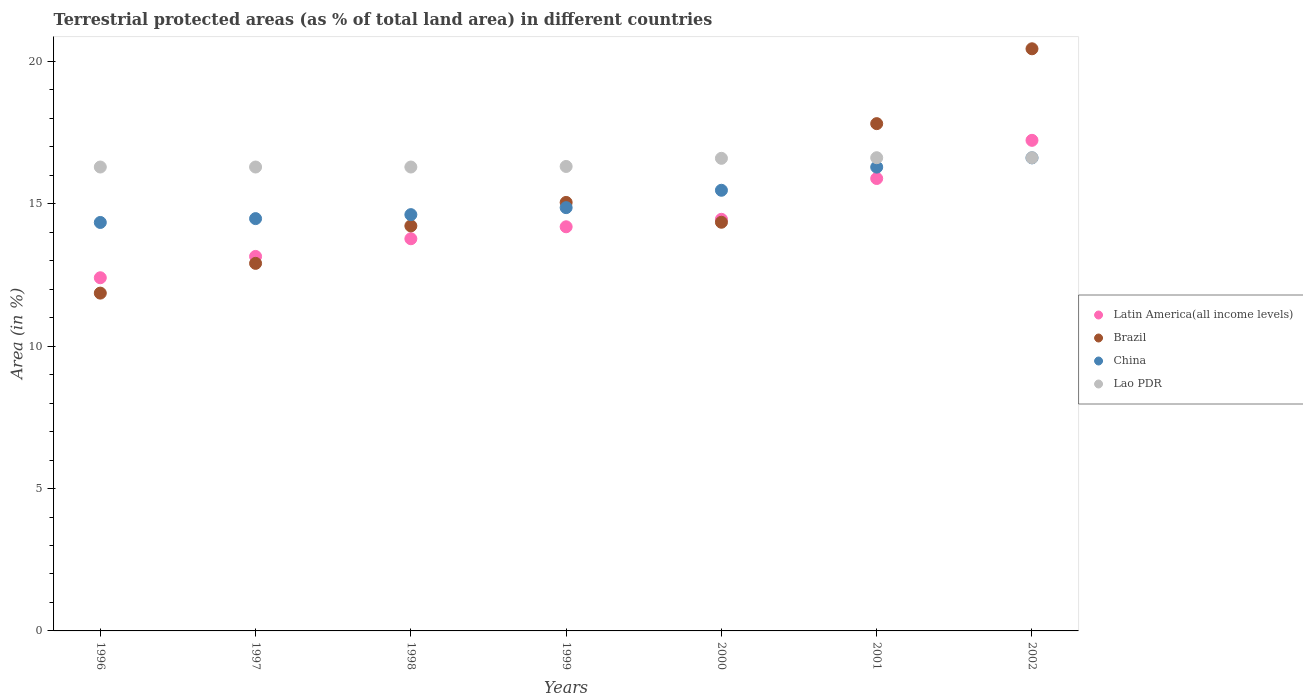What is the percentage of terrestrial protected land in China in 2001?
Offer a very short reply. 16.29. Across all years, what is the maximum percentage of terrestrial protected land in Latin America(all income levels)?
Give a very brief answer. 17.23. Across all years, what is the minimum percentage of terrestrial protected land in Latin America(all income levels)?
Provide a short and direct response. 12.4. In which year was the percentage of terrestrial protected land in Latin America(all income levels) maximum?
Keep it short and to the point. 2002. In which year was the percentage of terrestrial protected land in Lao PDR minimum?
Provide a short and direct response. 1996. What is the total percentage of terrestrial protected land in Latin America(all income levels) in the graph?
Offer a terse response. 101.09. What is the difference between the percentage of terrestrial protected land in China in 2000 and that in 2002?
Provide a succinct answer. -1.14. What is the difference between the percentage of terrestrial protected land in Latin America(all income levels) in 1997 and the percentage of terrestrial protected land in Brazil in 1999?
Offer a terse response. -1.9. What is the average percentage of terrestrial protected land in Brazil per year?
Provide a short and direct response. 15.24. In the year 2002, what is the difference between the percentage of terrestrial protected land in Brazil and percentage of terrestrial protected land in China?
Offer a terse response. 3.83. What is the ratio of the percentage of terrestrial protected land in Brazil in 1997 to that in 2002?
Provide a short and direct response. 0.63. Is the percentage of terrestrial protected land in China in 1999 less than that in 2001?
Provide a short and direct response. Yes. What is the difference between the highest and the second highest percentage of terrestrial protected land in Latin America(all income levels)?
Your answer should be compact. 1.34. What is the difference between the highest and the lowest percentage of terrestrial protected land in Latin America(all income levels)?
Give a very brief answer. 4.83. Is the sum of the percentage of terrestrial protected land in Lao PDR in 1998 and 2002 greater than the maximum percentage of terrestrial protected land in Brazil across all years?
Your response must be concise. Yes. Is it the case that in every year, the sum of the percentage of terrestrial protected land in Latin America(all income levels) and percentage of terrestrial protected land in China  is greater than the sum of percentage of terrestrial protected land in Lao PDR and percentage of terrestrial protected land in Brazil?
Your response must be concise. No. Does the percentage of terrestrial protected land in Brazil monotonically increase over the years?
Provide a succinct answer. No. Is the percentage of terrestrial protected land in Latin America(all income levels) strictly greater than the percentage of terrestrial protected land in Lao PDR over the years?
Make the answer very short. No. Is the percentage of terrestrial protected land in Brazil strictly less than the percentage of terrestrial protected land in Latin America(all income levels) over the years?
Your answer should be compact. No. How many dotlines are there?
Give a very brief answer. 4. How many years are there in the graph?
Provide a succinct answer. 7. Are the values on the major ticks of Y-axis written in scientific E-notation?
Provide a short and direct response. No. Does the graph contain any zero values?
Make the answer very short. No. Does the graph contain grids?
Ensure brevity in your answer.  No. Where does the legend appear in the graph?
Keep it short and to the point. Center right. How many legend labels are there?
Offer a very short reply. 4. How are the legend labels stacked?
Offer a very short reply. Vertical. What is the title of the graph?
Ensure brevity in your answer.  Terrestrial protected areas (as % of total land area) in different countries. Does "St. Lucia" appear as one of the legend labels in the graph?
Provide a succinct answer. No. What is the label or title of the Y-axis?
Your answer should be very brief. Area (in %). What is the Area (in %) in Latin America(all income levels) in 1996?
Offer a very short reply. 12.4. What is the Area (in %) in Brazil in 1996?
Ensure brevity in your answer.  11.86. What is the Area (in %) in China in 1996?
Your answer should be very brief. 14.34. What is the Area (in %) in Lao PDR in 1996?
Ensure brevity in your answer.  16.29. What is the Area (in %) of Latin America(all income levels) in 1997?
Provide a short and direct response. 13.15. What is the Area (in %) of Brazil in 1997?
Your answer should be compact. 12.91. What is the Area (in %) of China in 1997?
Ensure brevity in your answer.  14.48. What is the Area (in %) in Lao PDR in 1997?
Keep it short and to the point. 16.29. What is the Area (in %) of Latin America(all income levels) in 1998?
Your answer should be very brief. 13.77. What is the Area (in %) in Brazil in 1998?
Provide a succinct answer. 14.22. What is the Area (in %) of China in 1998?
Your answer should be compact. 14.62. What is the Area (in %) of Lao PDR in 1998?
Provide a short and direct response. 16.29. What is the Area (in %) of Latin America(all income levels) in 1999?
Offer a terse response. 14.19. What is the Area (in %) in Brazil in 1999?
Offer a terse response. 15.05. What is the Area (in %) in China in 1999?
Your response must be concise. 14.86. What is the Area (in %) of Lao PDR in 1999?
Your answer should be very brief. 16.31. What is the Area (in %) in Latin America(all income levels) in 2000?
Your answer should be compact. 14.46. What is the Area (in %) in Brazil in 2000?
Offer a very short reply. 14.35. What is the Area (in %) of China in 2000?
Offer a terse response. 15.47. What is the Area (in %) of Lao PDR in 2000?
Your response must be concise. 16.6. What is the Area (in %) of Latin America(all income levels) in 2001?
Keep it short and to the point. 15.89. What is the Area (in %) in Brazil in 2001?
Make the answer very short. 17.81. What is the Area (in %) in China in 2001?
Your answer should be compact. 16.29. What is the Area (in %) in Lao PDR in 2001?
Your answer should be very brief. 16.62. What is the Area (in %) in Latin America(all income levels) in 2002?
Offer a terse response. 17.23. What is the Area (in %) in Brazil in 2002?
Your answer should be very brief. 20.44. What is the Area (in %) of China in 2002?
Provide a short and direct response. 16.61. What is the Area (in %) of Lao PDR in 2002?
Provide a short and direct response. 16.62. Across all years, what is the maximum Area (in %) of Latin America(all income levels)?
Your response must be concise. 17.23. Across all years, what is the maximum Area (in %) of Brazil?
Offer a very short reply. 20.44. Across all years, what is the maximum Area (in %) in China?
Provide a short and direct response. 16.61. Across all years, what is the maximum Area (in %) of Lao PDR?
Provide a succinct answer. 16.62. Across all years, what is the minimum Area (in %) in Latin America(all income levels)?
Offer a terse response. 12.4. Across all years, what is the minimum Area (in %) of Brazil?
Your answer should be very brief. 11.86. Across all years, what is the minimum Area (in %) of China?
Provide a short and direct response. 14.34. Across all years, what is the minimum Area (in %) of Lao PDR?
Make the answer very short. 16.29. What is the total Area (in %) of Latin America(all income levels) in the graph?
Provide a short and direct response. 101.09. What is the total Area (in %) in Brazil in the graph?
Provide a short and direct response. 106.65. What is the total Area (in %) in China in the graph?
Give a very brief answer. 106.68. What is the total Area (in %) of Lao PDR in the graph?
Offer a terse response. 115.02. What is the difference between the Area (in %) of Latin America(all income levels) in 1996 and that in 1997?
Provide a succinct answer. -0.75. What is the difference between the Area (in %) in Brazil in 1996 and that in 1997?
Your answer should be compact. -1.04. What is the difference between the Area (in %) in China in 1996 and that in 1997?
Provide a succinct answer. -0.13. What is the difference between the Area (in %) of Lao PDR in 1996 and that in 1997?
Provide a short and direct response. 0. What is the difference between the Area (in %) in Latin America(all income levels) in 1996 and that in 1998?
Your response must be concise. -1.37. What is the difference between the Area (in %) of Brazil in 1996 and that in 1998?
Offer a very short reply. -2.36. What is the difference between the Area (in %) of China in 1996 and that in 1998?
Offer a very short reply. -0.27. What is the difference between the Area (in %) of Latin America(all income levels) in 1996 and that in 1999?
Your answer should be compact. -1.79. What is the difference between the Area (in %) in Brazil in 1996 and that in 1999?
Your answer should be very brief. -3.19. What is the difference between the Area (in %) in China in 1996 and that in 1999?
Keep it short and to the point. -0.52. What is the difference between the Area (in %) of Lao PDR in 1996 and that in 1999?
Keep it short and to the point. -0.02. What is the difference between the Area (in %) in Latin America(all income levels) in 1996 and that in 2000?
Make the answer very short. -2.05. What is the difference between the Area (in %) of Brazil in 1996 and that in 2000?
Provide a succinct answer. -2.49. What is the difference between the Area (in %) of China in 1996 and that in 2000?
Keep it short and to the point. -1.13. What is the difference between the Area (in %) of Lao PDR in 1996 and that in 2000?
Provide a succinct answer. -0.31. What is the difference between the Area (in %) of Latin America(all income levels) in 1996 and that in 2001?
Keep it short and to the point. -3.49. What is the difference between the Area (in %) in Brazil in 1996 and that in 2001?
Keep it short and to the point. -5.95. What is the difference between the Area (in %) of China in 1996 and that in 2001?
Provide a short and direct response. -1.94. What is the difference between the Area (in %) of Lao PDR in 1996 and that in 2001?
Provide a succinct answer. -0.33. What is the difference between the Area (in %) of Latin America(all income levels) in 1996 and that in 2002?
Make the answer very short. -4.83. What is the difference between the Area (in %) in Brazil in 1996 and that in 2002?
Your response must be concise. -8.58. What is the difference between the Area (in %) of China in 1996 and that in 2002?
Give a very brief answer. -2.27. What is the difference between the Area (in %) of Lao PDR in 1996 and that in 2002?
Make the answer very short. -0.33. What is the difference between the Area (in %) of Latin America(all income levels) in 1997 and that in 1998?
Offer a very short reply. -0.62. What is the difference between the Area (in %) of Brazil in 1997 and that in 1998?
Provide a short and direct response. -1.31. What is the difference between the Area (in %) of China in 1997 and that in 1998?
Provide a short and direct response. -0.14. What is the difference between the Area (in %) in Lao PDR in 1997 and that in 1998?
Keep it short and to the point. 0. What is the difference between the Area (in %) in Latin America(all income levels) in 1997 and that in 1999?
Give a very brief answer. -1.04. What is the difference between the Area (in %) of Brazil in 1997 and that in 1999?
Ensure brevity in your answer.  -2.14. What is the difference between the Area (in %) in China in 1997 and that in 1999?
Your answer should be very brief. -0.39. What is the difference between the Area (in %) of Lao PDR in 1997 and that in 1999?
Ensure brevity in your answer.  -0.02. What is the difference between the Area (in %) in Latin America(all income levels) in 1997 and that in 2000?
Provide a succinct answer. -1.3. What is the difference between the Area (in %) of Brazil in 1997 and that in 2000?
Ensure brevity in your answer.  -1.44. What is the difference between the Area (in %) of China in 1997 and that in 2000?
Ensure brevity in your answer.  -1. What is the difference between the Area (in %) in Lao PDR in 1997 and that in 2000?
Make the answer very short. -0.31. What is the difference between the Area (in %) in Latin America(all income levels) in 1997 and that in 2001?
Offer a terse response. -2.74. What is the difference between the Area (in %) in Brazil in 1997 and that in 2001?
Ensure brevity in your answer.  -4.91. What is the difference between the Area (in %) in China in 1997 and that in 2001?
Offer a very short reply. -1.81. What is the difference between the Area (in %) in Lao PDR in 1997 and that in 2001?
Offer a very short reply. -0.33. What is the difference between the Area (in %) in Latin America(all income levels) in 1997 and that in 2002?
Your answer should be very brief. -4.08. What is the difference between the Area (in %) in Brazil in 1997 and that in 2002?
Your answer should be very brief. -7.54. What is the difference between the Area (in %) of China in 1997 and that in 2002?
Offer a terse response. -2.13. What is the difference between the Area (in %) in Lao PDR in 1997 and that in 2002?
Ensure brevity in your answer.  -0.33. What is the difference between the Area (in %) of Latin America(all income levels) in 1998 and that in 1999?
Ensure brevity in your answer.  -0.42. What is the difference between the Area (in %) of Brazil in 1998 and that in 1999?
Give a very brief answer. -0.82. What is the difference between the Area (in %) in China in 1998 and that in 1999?
Provide a short and direct response. -0.25. What is the difference between the Area (in %) of Lao PDR in 1998 and that in 1999?
Make the answer very short. -0.02. What is the difference between the Area (in %) in Latin America(all income levels) in 1998 and that in 2000?
Ensure brevity in your answer.  -0.68. What is the difference between the Area (in %) in Brazil in 1998 and that in 2000?
Your answer should be very brief. -0.13. What is the difference between the Area (in %) of China in 1998 and that in 2000?
Your answer should be compact. -0.86. What is the difference between the Area (in %) in Lao PDR in 1998 and that in 2000?
Provide a succinct answer. -0.31. What is the difference between the Area (in %) in Latin America(all income levels) in 1998 and that in 2001?
Give a very brief answer. -2.12. What is the difference between the Area (in %) of Brazil in 1998 and that in 2001?
Ensure brevity in your answer.  -3.59. What is the difference between the Area (in %) in China in 1998 and that in 2001?
Provide a succinct answer. -1.67. What is the difference between the Area (in %) of Lao PDR in 1998 and that in 2001?
Give a very brief answer. -0.33. What is the difference between the Area (in %) in Latin America(all income levels) in 1998 and that in 2002?
Provide a short and direct response. -3.46. What is the difference between the Area (in %) in Brazil in 1998 and that in 2002?
Make the answer very short. -6.22. What is the difference between the Area (in %) of China in 1998 and that in 2002?
Your answer should be compact. -1.99. What is the difference between the Area (in %) in Lao PDR in 1998 and that in 2002?
Offer a terse response. -0.33. What is the difference between the Area (in %) in Latin America(all income levels) in 1999 and that in 2000?
Offer a very short reply. -0.26. What is the difference between the Area (in %) in Brazil in 1999 and that in 2000?
Make the answer very short. 0.7. What is the difference between the Area (in %) in China in 1999 and that in 2000?
Provide a short and direct response. -0.61. What is the difference between the Area (in %) in Lao PDR in 1999 and that in 2000?
Keep it short and to the point. -0.29. What is the difference between the Area (in %) in Latin America(all income levels) in 1999 and that in 2001?
Offer a terse response. -1.7. What is the difference between the Area (in %) in Brazil in 1999 and that in 2001?
Offer a terse response. -2.77. What is the difference between the Area (in %) of China in 1999 and that in 2001?
Keep it short and to the point. -1.42. What is the difference between the Area (in %) in Lao PDR in 1999 and that in 2001?
Provide a short and direct response. -0.31. What is the difference between the Area (in %) in Latin America(all income levels) in 1999 and that in 2002?
Provide a short and direct response. -3.04. What is the difference between the Area (in %) in Brazil in 1999 and that in 2002?
Make the answer very short. -5.4. What is the difference between the Area (in %) in China in 1999 and that in 2002?
Keep it short and to the point. -1.75. What is the difference between the Area (in %) of Lao PDR in 1999 and that in 2002?
Your answer should be very brief. -0.31. What is the difference between the Area (in %) of Latin America(all income levels) in 2000 and that in 2001?
Your response must be concise. -1.43. What is the difference between the Area (in %) in Brazil in 2000 and that in 2001?
Give a very brief answer. -3.46. What is the difference between the Area (in %) in China in 2000 and that in 2001?
Your response must be concise. -0.81. What is the difference between the Area (in %) of Lao PDR in 2000 and that in 2001?
Your answer should be compact. -0.02. What is the difference between the Area (in %) in Latin America(all income levels) in 2000 and that in 2002?
Your answer should be very brief. -2.77. What is the difference between the Area (in %) in Brazil in 2000 and that in 2002?
Provide a succinct answer. -6.09. What is the difference between the Area (in %) of China in 2000 and that in 2002?
Provide a succinct answer. -1.14. What is the difference between the Area (in %) of Lao PDR in 2000 and that in 2002?
Your answer should be compact. -0.02. What is the difference between the Area (in %) in Latin America(all income levels) in 2001 and that in 2002?
Your answer should be very brief. -1.34. What is the difference between the Area (in %) of Brazil in 2001 and that in 2002?
Ensure brevity in your answer.  -2.63. What is the difference between the Area (in %) in China in 2001 and that in 2002?
Offer a terse response. -0.33. What is the difference between the Area (in %) of Latin America(all income levels) in 1996 and the Area (in %) of Brazil in 1997?
Keep it short and to the point. -0.51. What is the difference between the Area (in %) in Latin America(all income levels) in 1996 and the Area (in %) in China in 1997?
Your response must be concise. -2.08. What is the difference between the Area (in %) of Latin America(all income levels) in 1996 and the Area (in %) of Lao PDR in 1997?
Your answer should be compact. -3.89. What is the difference between the Area (in %) in Brazil in 1996 and the Area (in %) in China in 1997?
Give a very brief answer. -2.62. What is the difference between the Area (in %) in Brazil in 1996 and the Area (in %) in Lao PDR in 1997?
Provide a succinct answer. -4.43. What is the difference between the Area (in %) of China in 1996 and the Area (in %) of Lao PDR in 1997?
Make the answer very short. -1.95. What is the difference between the Area (in %) of Latin America(all income levels) in 1996 and the Area (in %) of Brazil in 1998?
Provide a short and direct response. -1.82. What is the difference between the Area (in %) of Latin America(all income levels) in 1996 and the Area (in %) of China in 1998?
Your answer should be compact. -2.22. What is the difference between the Area (in %) of Latin America(all income levels) in 1996 and the Area (in %) of Lao PDR in 1998?
Your answer should be compact. -3.89. What is the difference between the Area (in %) in Brazil in 1996 and the Area (in %) in China in 1998?
Ensure brevity in your answer.  -2.76. What is the difference between the Area (in %) in Brazil in 1996 and the Area (in %) in Lao PDR in 1998?
Provide a short and direct response. -4.43. What is the difference between the Area (in %) in China in 1996 and the Area (in %) in Lao PDR in 1998?
Offer a very short reply. -1.95. What is the difference between the Area (in %) in Latin America(all income levels) in 1996 and the Area (in %) in Brazil in 1999?
Ensure brevity in your answer.  -2.65. What is the difference between the Area (in %) in Latin America(all income levels) in 1996 and the Area (in %) in China in 1999?
Offer a very short reply. -2.46. What is the difference between the Area (in %) of Latin America(all income levels) in 1996 and the Area (in %) of Lao PDR in 1999?
Offer a terse response. -3.91. What is the difference between the Area (in %) of Brazil in 1996 and the Area (in %) of China in 1999?
Your answer should be very brief. -3. What is the difference between the Area (in %) in Brazil in 1996 and the Area (in %) in Lao PDR in 1999?
Provide a short and direct response. -4.45. What is the difference between the Area (in %) in China in 1996 and the Area (in %) in Lao PDR in 1999?
Provide a succinct answer. -1.97. What is the difference between the Area (in %) in Latin America(all income levels) in 1996 and the Area (in %) in Brazil in 2000?
Provide a short and direct response. -1.95. What is the difference between the Area (in %) of Latin America(all income levels) in 1996 and the Area (in %) of China in 2000?
Your response must be concise. -3.07. What is the difference between the Area (in %) of Latin America(all income levels) in 1996 and the Area (in %) of Lao PDR in 2000?
Your answer should be very brief. -4.19. What is the difference between the Area (in %) in Brazil in 1996 and the Area (in %) in China in 2000?
Offer a very short reply. -3.61. What is the difference between the Area (in %) in Brazil in 1996 and the Area (in %) in Lao PDR in 2000?
Give a very brief answer. -4.73. What is the difference between the Area (in %) of China in 1996 and the Area (in %) of Lao PDR in 2000?
Give a very brief answer. -2.25. What is the difference between the Area (in %) in Latin America(all income levels) in 1996 and the Area (in %) in Brazil in 2001?
Make the answer very short. -5.41. What is the difference between the Area (in %) in Latin America(all income levels) in 1996 and the Area (in %) in China in 2001?
Offer a terse response. -3.88. What is the difference between the Area (in %) of Latin America(all income levels) in 1996 and the Area (in %) of Lao PDR in 2001?
Offer a terse response. -4.22. What is the difference between the Area (in %) of Brazil in 1996 and the Area (in %) of China in 2001?
Provide a short and direct response. -4.42. What is the difference between the Area (in %) in Brazil in 1996 and the Area (in %) in Lao PDR in 2001?
Ensure brevity in your answer.  -4.76. What is the difference between the Area (in %) of China in 1996 and the Area (in %) of Lao PDR in 2001?
Offer a very short reply. -2.27. What is the difference between the Area (in %) of Latin America(all income levels) in 1996 and the Area (in %) of Brazil in 2002?
Ensure brevity in your answer.  -8.04. What is the difference between the Area (in %) in Latin America(all income levels) in 1996 and the Area (in %) in China in 2002?
Offer a very short reply. -4.21. What is the difference between the Area (in %) in Latin America(all income levels) in 1996 and the Area (in %) in Lao PDR in 2002?
Your answer should be very brief. -4.22. What is the difference between the Area (in %) of Brazil in 1996 and the Area (in %) of China in 2002?
Your response must be concise. -4.75. What is the difference between the Area (in %) in Brazil in 1996 and the Area (in %) in Lao PDR in 2002?
Give a very brief answer. -4.76. What is the difference between the Area (in %) of China in 1996 and the Area (in %) of Lao PDR in 2002?
Give a very brief answer. -2.27. What is the difference between the Area (in %) in Latin America(all income levels) in 1997 and the Area (in %) in Brazil in 1998?
Offer a terse response. -1.07. What is the difference between the Area (in %) of Latin America(all income levels) in 1997 and the Area (in %) of China in 1998?
Offer a terse response. -1.47. What is the difference between the Area (in %) of Latin America(all income levels) in 1997 and the Area (in %) of Lao PDR in 1998?
Provide a short and direct response. -3.14. What is the difference between the Area (in %) of Brazil in 1997 and the Area (in %) of China in 1998?
Offer a very short reply. -1.71. What is the difference between the Area (in %) of Brazil in 1997 and the Area (in %) of Lao PDR in 1998?
Give a very brief answer. -3.38. What is the difference between the Area (in %) of China in 1997 and the Area (in %) of Lao PDR in 1998?
Make the answer very short. -1.81. What is the difference between the Area (in %) of Latin America(all income levels) in 1997 and the Area (in %) of Brazil in 1999?
Give a very brief answer. -1.9. What is the difference between the Area (in %) of Latin America(all income levels) in 1997 and the Area (in %) of China in 1999?
Your answer should be very brief. -1.71. What is the difference between the Area (in %) in Latin America(all income levels) in 1997 and the Area (in %) in Lao PDR in 1999?
Your response must be concise. -3.16. What is the difference between the Area (in %) in Brazil in 1997 and the Area (in %) in China in 1999?
Provide a short and direct response. -1.96. What is the difference between the Area (in %) of Brazil in 1997 and the Area (in %) of Lao PDR in 1999?
Keep it short and to the point. -3.4. What is the difference between the Area (in %) in China in 1997 and the Area (in %) in Lao PDR in 1999?
Provide a short and direct response. -1.83. What is the difference between the Area (in %) of Latin America(all income levels) in 1997 and the Area (in %) of Brazil in 2000?
Offer a very short reply. -1.2. What is the difference between the Area (in %) in Latin America(all income levels) in 1997 and the Area (in %) in China in 2000?
Offer a very short reply. -2.32. What is the difference between the Area (in %) in Latin America(all income levels) in 1997 and the Area (in %) in Lao PDR in 2000?
Make the answer very short. -3.45. What is the difference between the Area (in %) in Brazil in 1997 and the Area (in %) in China in 2000?
Offer a very short reply. -2.57. What is the difference between the Area (in %) of Brazil in 1997 and the Area (in %) of Lao PDR in 2000?
Give a very brief answer. -3.69. What is the difference between the Area (in %) of China in 1997 and the Area (in %) of Lao PDR in 2000?
Your answer should be very brief. -2.12. What is the difference between the Area (in %) of Latin America(all income levels) in 1997 and the Area (in %) of Brazil in 2001?
Offer a terse response. -4.66. What is the difference between the Area (in %) in Latin America(all income levels) in 1997 and the Area (in %) in China in 2001?
Your answer should be very brief. -3.14. What is the difference between the Area (in %) of Latin America(all income levels) in 1997 and the Area (in %) of Lao PDR in 2001?
Provide a short and direct response. -3.47. What is the difference between the Area (in %) in Brazil in 1997 and the Area (in %) in China in 2001?
Offer a very short reply. -3.38. What is the difference between the Area (in %) in Brazil in 1997 and the Area (in %) in Lao PDR in 2001?
Give a very brief answer. -3.71. What is the difference between the Area (in %) in China in 1997 and the Area (in %) in Lao PDR in 2001?
Ensure brevity in your answer.  -2.14. What is the difference between the Area (in %) in Latin America(all income levels) in 1997 and the Area (in %) in Brazil in 2002?
Your answer should be very brief. -7.29. What is the difference between the Area (in %) in Latin America(all income levels) in 1997 and the Area (in %) in China in 2002?
Your response must be concise. -3.46. What is the difference between the Area (in %) in Latin America(all income levels) in 1997 and the Area (in %) in Lao PDR in 2002?
Ensure brevity in your answer.  -3.47. What is the difference between the Area (in %) in Brazil in 1997 and the Area (in %) in China in 2002?
Keep it short and to the point. -3.71. What is the difference between the Area (in %) of Brazil in 1997 and the Area (in %) of Lao PDR in 2002?
Provide a short and direct response. -3.71. What is the difference between the Area (in %) in China in 1997 and the Area (in %) in Lao PDR in 2002?
Provide a succinct answer. -2.14. What is the difference between the Area (in %) in Latin America(all income levels) in 1998 and the Area (in %) in Brazil in 1999?
Keep it short and to the point. -1.28. What is the difference between the Area (in %) in Latin America(all income levels) in 1998 and the Area (in %) in China in 1999?
Your response must be concise. -1.09. What is the difference between the Area (in %) in Latin America(all income levels) in 1998 and the Area (in %) in Lao PDR in 1999?
Offer a very short reply. -2.54. What is the difference between the Area (in %) in Brazil in 1998 and the Area (in %) in China in 1999?
Offer a terse response. -0.64. What is the difference between the Area (in %) of Brazil in 1998 and the Area (in %) of Lao PDR in 1999?
Offer a very short reply. -2.09. What is the difference between the Area (in %) in China in 1998 and the Area (in %) in Lao PDR in 1999?
Your answer should be compact. -1.69. What is the difference between the Area (in %) in Latin America(all income levels) in 1998 and the Area (in %) in Brazil in 2000?
Offer a very short reply. -0.58. What is the difference between the Area (in %) in Latin America(all income levels) in 1998 and the Area (in %) in China in 2000?
Offer a very short reply. -1.7. What is the difference between the Area (in %) in Latin America(all income levels) in 1998 and the Area (in %) in Lao PDR in 2000?
Make the answer very short. -2.82. What is the difference between the Area (in %) of Brazil in 1998 and the Area (in %) of China in 2000?
Provide a succinct answer. -1.25. What is the difference between the Area (in %) of Brazil in 1998 and the Area (in %) of Lao PDR in 2000?
Give a very brief answer. -2.37. What is the difference between the Area (in %) of China in 1998 and the Area (in %) of Lao PDR in 2000?
Offer a very short reply. -1.98. What is the difference between the Area (in %) of Latin America(all income levels) in 1998 and the Area (in %) of Brazil in 2001?
Ensure brevity in your answer.  -4.04. What is the difference between the Area (in %) in Latin America(all income levels) in 1998 and the Area (in %) in China in 2001?
Provide a short and direct response. -2.52. What is the difference between the Area (in %) in Latin America(all income levels) in 1998 and the Area (in %) in Lao PDR in 2001?
Your answer should be compact. -2.85. What is the difference between the Area (in %) of Brazil in 1998 and the Area (in %) of China in 2001?
Give a very brief answer. -2.06. What is the difference between the Area (in %) of Brazil in 1998 and the Area (in %) of Lao PDR in 2001?
Your response must be concise. -2.4. What is the difference between the Area (in %) in China in 1998 and the Area (in %) in Lao PDR in 2001?
Your response must be concise. -2. What is the difference between the Area (in %) of Latin America(all income levels) in 1998 and the Area (in %) of Brazil in 2002?
Make the answer very short. -6.67. What is the difference between the Area (in %) in Latin America(all income levels) in 1998 and the Area (in %) in China in 2002?
Provide a short and direct response. -2.84. What is the difference between the Area (in %) in Latin America(all income levels) in 1998 and the Area (in %) in Lao PDR in 2002?
Your answer should be compact. -2.85. What is the difference between the Area (in %) in Brazil in 1998 and the Area (in %) in China in 2002?
Keep it short and to the point. -2.39. What is the difference between the Area (in %) in Brazil in 1998 and the Area (in %) in Lao PDR in 2002?
Your answer should be very brief. -2.4. What is the difference between the Area (in %) of China in 1998 and the Area (in %) of Lao PDR in 2002?
Provide a succinct answer. -2. What is the difference between the Area (in %) of Latin America(all income levels) in 1999 and the Area (in %) of Brazil in 2000?
Offer a very short reply. -0.16. What is the difference between the Area (in %) of Latin America(all income levels) in 1999 and the Area (in %) of China in 2000?
Make the answer very short. -1.28. What is the difference between the Area (in %) of Latin America(all income levels) in 1999 and the Area (in %) of Lao PDR in 2000?
Make the answer very short. -2.4. What is the difference between the Area (in %) of Brazil in 1999 and the Area (in %) of China in 2000?
Offer a terse response. -0.43. What is the difference between the Area (in %) in Brazil in 1999 and the Area (in %) in Lao PDR in 2000?
Your answer should be compact. -1.55. What is the difference between the Area (in %) in China in 1999 and the Area (in %) in Lao PDR in 2000?
Give a very brief answer. -1.73. What is the difference between the Area (in %) in Latin America(all income levels) in 1999 and the Area (in %) in Brazil in 2001?
Make the answer very short. -3.62. What is the difference between the Area (in %) in Latin America(all income levels) in 1999 and the Area (in %) in China in 2001?
Give a very brief answer. -2.1. What is the difference between the Area (in %) of Latin America(all income levels) in 1999 and the Area (in %) of Lao PDR in 2001?
Provide a succinct answer. -2.43. What is the difference between the Area (in %) in Brazil in 1999 and the Area (in %) in China in 2001?
Offer a terse response. -1.24. What is the difference between the Area (in %) in Brazil in 1999 and the Area (in %) in Lao PDR in 2001?
Ensure brevity in your answer.  -1.57. What is the difference between the Area (in %) in China in 1999 and the Area (in %) in Lao PDR in 2001?
Keep it short and to the point. -1.75. What is the difference between the Area (in %) in Latin America(all income levels) in 1999 and the Area (in %) in Brazil in 2002?
Provide a short and direct response. -6.25. What is the difference between the Area (in %) of Latin America(all income levels) in 1999 and the Area (in %) of China in 2002?
Provide a short and direct response. -2.42. What is the difference between the Area (in %) of Latin America(all income levels) in 1999 and the Area (in %) of Lao PDR in 2002?
Your response must be concise. -2.43. What is the difference between the Area (in %) of Brazil in 1999 and the Area (in %) of China in 2002?
Your answer should be compact. -1.57. What is the difference between the Area (in %) in Brazil in 1999 and the Area (in %) in Lao PDR in 2002?
Provide a short and direct response. -1.57. What is the difference between the Area (in %) of China in 1999 and the Area (in %) of Lao PDR in 2002?
Make the answer very short. -1.75. What is the difference between the Area (in %) of Latin America(all income levels) in 2000 and the Area (in %) of Brazil in 2001?
Provide a succinct answer. -3.36. What is the difference between the Area (in %) in Latin America(all income levels) in 2000 and the Area (in %) in China in 2001?
Keep it short and to the point. -1.83. What is the difference between the Area (in %) in Latin America(all income levels) in 2000 and the Area (in %) in Lao PDR in 2001?
Provide a short and direct response. -2.16. What is the difference between the Area (in %) in Brazil in 2000 and the Area (in %) in China in 2001?
Ensure brevity in your answer.  -1.94. What is the difference between the Area (in %) of Brazil in 2000 and the Area (in %) of Lao PDR in 2001?
Your answer should be compact. -2.27. What is the difference between the Area (in %) of China in 2000 and the Area (in %) of Lao PDR in 2001?
Make the answer very short. -1.14. What is the difference between the Area (in %) of Latin America(all income levels) in 2000 and the Area (in %) of Brazil in 2002?
Your response must be concise. -5.99. What is the difference between the Area (in %) in Latin America(all income levels) in 2000 and the Area (in %) in China in 2002?
Make the answer very short. -2.16. What is the difference between the Area (in %) in Latin America(all income levels) in 2000 and the Area (in %) in Lao PDR in 2002?
Offer a very short reply. -2.16. What is the difference between the Area (in %) of Brazil in 2000 and the Area (in %) of China in 2002?
Make the answer very short. -2.26. What is the difference between the Area (in %) of Brazil in 2000 and the Area (in %) of Lao PDR in 2002?
Give a very brief answer. -2.27. What is the difference between the Area (in %) of China in 2000 and the Area (in %) of Lao PDR in 2002?
Provide a succinct answer. -1.14. What is the difference between the Area (in %) in Latin America(all income levels) in 2001 and the Area (in %) in Brazil in 2002?
Offer a very short reply. -4.56. What is the difference between the Area (in %) of Latin America(all income levels) in 2001 and the Area (in %) of China in 2002?
Keep it short and to the point. -0.73. What is the difference between the Area (in %) of Latin America(all income levels) in 2001 and the Area (in %) of Lao PDR in 2002?
Offer a terse response. -0.73. What is the difference between the Area (in %) in Brazil in 2001 and the Area (in %) in China in 2002?
Provide a short and direct response. 1.2. What is the difference between the Area (in %) in Brazil in 2001 and the Area (in %) in Lao PDR in 2002?
Offer a terse response. 1.2. What is the difference between the Area (in %) of China in 2001 and the Area (in %) of Lao PDR in 2002?
Your response must be concise. -0.33. What is the average Area (in %) of Latin America(all income levels) per year?
Offer a terse response. 14.44. What is the average Area (in %) of Brazil per year?
Ensure brevity in your answer.  15.24. What is the average Area (in %) in China per year?
Offer a terse response. 15.24. What is the average Area (in %) in Lao PDR per year?
Provide a succinct answer. 16.43. In the year 1996, what is the difference between the Area (in %) of Latin America(all income levels) and Area (in %) of Brazil?
Keep it short and to the point. 0.54. In the year 1996, what is the difference between the Area (in %) in Latin America(all income levels) and Area (in %) in China?
Your answer should be very brief. -1.94. In the year 1996, what is the difference between the Area (in %) of Latin America(all income levels) and Area (in %) of Lao PDR?
Give a very brief answer. -3.89. In the year 1996, what is the difference between the Area (in %) of Brazil and Area (in %) of China?
Give a very brief answer. -2.48. In the year 1996, what is the difference between the Area (in %) in Brazil and Area (in %) in Lao PDR?
Keep it short and to the point. -4.43. In the year 1996, what is the difference between the Area (in %) in China and Area (in %) in Lao PDR?
Provide a short and direct response. -1.95. In the year 1997, what is the difference between the Area (in %) of Latin America(all income levels) and Area (in %) of Brazil?
Your answer should be compact. 0.24. In the year 1997, what is the difference between the Area (in %) of Latin America(all income levels) and Area (in %) of China?
Provide a succinct answer. -1.33. In the year 1997, what is the difference between the Area (in %) in Latin America(all income levels) and Area (in %) in Lao PDR?
Ensure brevity in your answer.  -3.14. In the year 1997, what is the difference between the Area (in %) of Brazil and Area (in %) of China?
Provide a short and direct response. -1.57. In the year 1997, what is the difference between the Area (in %) in Brazil and Area (in %) in Lao PDR?
Provide a short and direct response. -3.38. In the year 1997, what is the difference between the Area (in %) of China and Area (in %) of Lao PDR?
Provide a short and direct response. -1.81. In the year 1998, what is the difference between the Area (in %) of Latin America(all income levels) and Area (in %) of Brazil?
Provide a succinct answer. -0.45. In the year 1998, what is the difference between the Area (in %) of Latin America(all income levels) and Area (in %) of China?
Your answer should be compact. -0.85. In the year 1998, what is the difference between the Area (in %) of Latin America(all income levels) and Area (in %) of Lao PDR?
Ensure brevity in your answer.  -2.52. In the year 1998, what is the difference between the Area (in %) of Brazil and Area (in %) of China?
Ensure brevity in your answer.  -0.4. In the year 1998, what is the difference between the Area (in %) of Brazil and Area (in %) of Lao PDR?
Offer a very short reply. -2.07. In the year 1998, what is the difference between the Area (in %) of China and Area (in %) of Lao PDR?
Offer a very short reply. -1.67. In the year 1999, what is the difference between the Area (in %) of Latin America(all income levels) and Area (in %) of Brazil?
Keep it short and to the point. -0.86. In the year 1999, what is the difference between the Area (in %) of Latin America(all income levels) and Area (in %) of China?
Provide a succinct answer. -0.67. In the year 1999, what is the difference between the Area (in %) of Latin America(all income levels) and Area (in %) of Lao PDR?
Give a very brief answer. -2.12. In the year 1999, what is the difference between the Area (in %) of Brazil and Area (in %) of China?
Make the answer very short. 0.18. In the year 1999, what is the difference between the Area (in %) in Brazil and Area (in %) in Lao PDR?
Offer a very short reply. -1.26. In the year 1999, what is the difference between the Area (in %) of China and Area (in %) of Lao PDR?
Your response must be concise. -1.45. In the year 2000, what is the difference between the Area (in %) in Latin America(all income levels) and Area (in %) in Brazil?
Give a very brief answer. 0.1. In the year 2000, what is the difference between the Area (in %) in Latin America(all income levels) and Area (in %) in China?
Give a very brief answer. -1.02. In the year 2000, what is the difference between the Area (in %) in Latin America(all income levels) and Area (in %) in Lao PDR?
Make the answer very short. -2.14. In the year 2000, what is the difference between the Area (in %) in Brazil and Area (in %) in China?
Your answer should be compact. -1.12. In the year 2000, what is the difference between the Area (in %) of Brazil and Area (in %) of Lao PDR?
Ensure brevity in your answer.  -2.25. In the year 2000, what is the difference between the Area (in %) in China and Area (in %) in Lao PDR?
Provide a succinct answer. -1.12. In the year 2001, what is the difference between the Area (in %) of Latin America(all income levels) and Area (in %) of Brazil?
Offer a very short reply. -1.93. In the year 2001, what is the difference between the Area (in %) of Latin America(all income levels) and Area (in %) of China?
Make the answer very short. -0.4. In the year 2001, what is the difference between the Area (in %) of Latin America(all income levels) and Area (in %) of Lao PDR?
Keep it short and to the point. -0.73. In the year 2001, what is the difference between the Area (in %) of Brazil and Area (in %) of China?
Your response must be concise. 1.53. In the year 2001, what is the difference between the Area (in %) of Brazil and Area (in %) of Lao PDR?
Your answer should be compact. 1.2. In the year 2001, what is the difference between the Area (in %) of China and Area (in %) of Lao PDR?
Provide a succinct answer. -0.33. In the year 2002, what is the difference between the Area (in %) of Latin America(all income levels) and Area (in %) of Brazil?
Give a very brief answer. -3.21. In the year 2002, what is the difference between the Area (in %) of Latin America(all income levels) and Area (in %) of China?
Offer a terse response. 0.62. In the year 2002, what is the difference between the Area (in %) in Latin America(all income levels) and Area (in %) in Lao PDR?
Keep it short and to the point. 0.61. In the year 2002, what is the difference between the Area (in %) in Brazil and Area (in %) in China?
Your answer should be very brief. 3.83. In the year 2002, what is the difference between the Area (in %) in Brazil and Area (in %) in Lao PDR?
Offer a terse response. 3.83. In the year 2002, what is the difference between the Area (in %) in China and Area (in %) in Lao PDR?
Your answer should be very brief. -0.01. What is the ratio of the Area (in %) in Latin America(all income levels) in 1996 to that in 1997?
Provide a succinct answer. 0.94. What is the ratio of the Area (in %) of Brazil in 1996 to that in 1997?
Give a very brief answer. 0.92. What is the ratio of the Area (in %) of Lao PDR in 1996 to that in 1997?
Make the answer very short. 1. What is the ratio of the Area (in %) in Latin America(all income levels) in 1996 to that in 1998?
Give a very brief answer. 0.9. What is the ratio of the Area (in %) in Brazil in 1996 to that in 1998?
Your response must be concise. 0.83. What is the ratio of the Area (in %) in China in 1996 to that in 1998?
Keep it short and to the point. 0.98. What is the ratio of the Area (in %) of Latin America(all income levels) in 1996 to that in 1999?
Give a very brief answer. 0.87. What is the ratio of the Area (in %) in Brazil in 1996 to that in 1999?
Offer a very short reply. 0.79. What is the ratio of the Area (in %) of China in 1996 to that in 1999?
Your answer should be very brief. 0.96. What is the ratio of the Area (in %) in Lao PDR in 1996 to that in 1999?
Keep it short and to the point. 1. What is the ratio of the Area (in %) in Latin America(all income levels) in 1996 to that in 2000?
Provide a succinct answer. 0.86. What is the ratio of the Area (in %) of Brazil in 1996 to that in 2000?
Provide a succinct answer. 0.83. What is the ratio of the Area (in %) in China in 1996 to that in 2000?
Your answer should be compact. 0.93. What is the ratio of the Area (in %) of Lao PDR in 1996 to that in 2000?
Your response must be concise. 0.98. What is the ratio of the Area (in %) in Latin America(all income levels) in 1996 to that in 2001?
Provide a short and direct response. 0.78. What is the ratio of the Area (in %) of Brazil in 1996 to that in 2001?
Provide a short and direct response. 0.67. What is the ratio of the Area (in %) in China in 1996 to that in 2001?
Provide a succinct answer. 0.88. What is the ratio of the Area (in %) of Lao PDR in 1996 to that in 2001?
Keep it short and to the point. 0.98. What is the ratio of the Area (in %) of Latin America(all income levels) in 1996 to that in 2002?
Keep it short and to the point. 0.72. What is the ratio of the Area (in %) in Brazil in 1996 to that in 2002?
Provide a short and direct response. 0.58. What is the ratio of the Area (in %) in China in 1996 to that in 2002?
Your answer should be very brief. 0.86. What is the ratio of the Area (in %) of Lao PDR in 1996 to that in 2002?
Ensure brevity in your answer.  0.98. What is the ratio of the Area (in %) of Latin America(all income levels) in 1997 to that in 1998?
Your answer should be compact. 0.95. What is the ratio of the Area (in %) of Brazil in 1997 to that in 1998?
Provide a short and direct response. 0.91. What is the ratio of the Area (in %) of Latin America(all income levels) in 1997 to that in 1999?
Your response must be concise. 0.93. What is the ratio of the Area (in %) of Brazil in 1997 to that in 1999?
Give a very brief answer. 0.86. What is the ratio of the Area (in %) of China in 1997 to that in 1999?
Offer a very short reply. 0.97. What is the ratio of the Area (in %) of Latin America(all income levels) in 1997 to that in 2000?
Keep it short and to the point. 0.91. What is the ratio of the Area (in %) of Brazil in 1997 to that in 2000?
Provide a short and direct response. 0.9. What is the ratio of the Area (in %) in China in 1997 to that in 2000?
Ensure brevity in your answer.  0.94. What is the ratio of the Area (in %) of Lao PDR in 1997 to that in 2000?
Your response must be concise. 0.98. What is the ratio of the Area (in %) of Latin America(all income levels) in 1997 to that in 2001?
Your answer should be compact. 0.83. What is the ratio of the Area (in %) of Brazil in 1997 to that in 2001?
Ensure brevity in your answer.  0.72. What is the ratio of the Area (in %) in China in 1997 to that in 2001?
Your answer should be very brief. 0.89. What is the ratio of the Area (in %) of Lao PDR in 1997 to that in 2001?
Give a very brief answer. 0.98. What is the ratio of the Area (in %) of Latin America(all income levels) in 1997 to that in 2002?
Give a very brief answer. 0.76. What is the ratio of the Area (in %) in Brazil in 1997 to that in 2002?
Offer a very short reply. 0.63. What is the ratio of the Area (in %) in China in 1997 to that in 2002?
Provide a short and direct response. 0.87. What is the ratio of the Area (in %) of Lao PDR in 1997 to that in 2002?
Offer a terse response. 0.98. What is the ratio of the Area (in %) of Latin America(all income levels) in 1998 to that in 1999?
Your answer should be very brief. 0.97. What is the ratio of the Area (in %) in Brazil in 1998 to that in 1999?
Provide a short and direct response. 0.95. What is the ratio of the Area (in %) of China in 1998 to that in 1999?
Make the answer very short. 0.98. What is the ratio of the Area (in %) of Latin America(all income levels) in 1998 to that in 2000?
Give a very brief answer. 0.95. What is the ratio of the Area (in %) in China in 1998 to that in 2000?
Make the answer very short. 0.94. What is the ratio of the Area (in %) of Lao PDR in 1998 to that in 2000?
Make the answer very short. 0.98. What is the ratio of the Area (in %) in Latin America(all income levels) in 1998 to that in 2001?
Make the answer very short. 0.87. What is the ratio of the Area (in %) of Brazil in 1998 to that in 2001?
Ensure brevity in your answer.  0.8. What is the ratio of the Area (in %) of China in 1998 to that in 2001?
Make the answer very short. 0.9. What is the ratio of the Area (in %) of Lao PDR in 1998 to that in 2001?
Provide a short and direct response. 0.98. What is the ratio of the Area (in %) in Latin America(all income levels) in 1998 to that in 2002?
Keep it short and to the point. 0.8. What is the ratio of the Area (in %) of Brazil in 1998 to that in 2002?
Ensure brevity in your answer.  0.7. What is the ratio of the Area (in %) of Lao PDR in 1998 to that in 2002?
Provide a short and direct response. 0.98. What is the ratio of the Area (in %) in Latin America(all income levels) in 1999 to that in 2000?
Your answer should be very brief. 0.98. What is the ratio of the Area (in %) of Brazil in 1999 to that in 2000?
Make the answer very short. 1.05. What is the ratio of the Area (in %) in China in 1999 to that in 2000?
Keep it short and to the point. 0.96. What is the ratio of the Area (in %) of Lao PDR in 1999 to that in 2000?
Keep it short and to the point. 0.98. What is the ratio of the Area (in %) in Latin America(all income levels) in 1999 to that in 2001?
Give a very brief answer. 0.89. What is the ratio of the Area (in %) of Brazil in 1999 to that in 2001?
Your answer should be compact. 0.84. What is the ratio of the Area (in %) of China in 1999 to that in 2001?
Make the answer very short. 0.91. What is the ratio of the Area (in %) in Lao PDR in 1999 to that in 2001?
Make the answer very short. 0.98. What is the ratio of the Area (in %) in Latin America(all income levels) in 1999 to that in 2002?
Make the answer very short. 0.82. What is the ratio of the Area (in %) in Brazil in 1999 to that in 2002?
Your answer should be very brief. 0.74. What is the ratio of the Area (in %) of China in 1999 to that in 2002?
Offer a terse response. 0.89. What is the ratio of the Area (in %) in Lao PDR in 1999 to that in 2002?
Give a very brief answer. 0.98. What is the ratio of the Area (in %) of Latin America(all income levels) in 2000 to that in 2001?
Give a very brief answer. 0.91. What is the ratio of the Area (in %) of Brazil in 2000 to that in 2001?
Keep it short and to the point. 0.81. What is the ratio of the Area (in %) of China in 2000 to that in 2001?
Offer a terse response. 0.95. What is the ratio of the Area (in %) in Latin America(all income levels) in 2000 to that in 2002?
Your answer should be very brief. 0.84. What is the ratio of the Area (in %) in Brazil in 2000 to that in 2002?
Your response must be concise. 0.7. What is the ratio of the Area (in %) of China in 2000 to that in 2002?
Make the answer very short. 0.93. What is the ratio of the Area (in %) in Latin America(all income levels) in 2001 to that in 2002?
Make the answer very short. 0.92. What is the ratio of the Area (in %) of Brazil in 2001 to that in 2002?
Provide a short and direct response. 0.87. What is the ratio of the Area (in %) in China in 2001 to that in 2002?
Make the answer very short. 0.98. What is the ratio of the Area (in %) in Lao PDR in 2001 to that in 2002?
Provide a succinct answer. 1. What is the difference between the highest and the second highest Area (in %) in Latin America(all income levels)?
Your answer should be very brief. 1.34. What is the difference between the highest and the second highest Area (in %) in Brazil?
Keep it short and to the point. 2.63. What is the difference between the highest and the second highest Area (in %) in China?
Keep it short and to the point. 0.33. What is the difference between the highest and the lowest Area (in %) of Latin America(all income levels)?
Keep it short and to the point. 4.83. What is the difference between the highest and the lowest Area (in %) of Brazil?
Ensure brevity in your answer.  8.58. What is the difference between the highest and the lowest Area (in %) of China?
Your answer should be very brief. 2.27. What is the difference between the highest and the lowest Area (in %) of Lao PDR?
Your response must be concise. 0.33. 